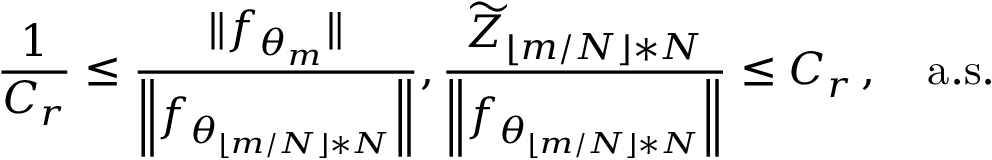<formula> <loc_0><loc_0><loc_500><loc_500>\frac { 1 } { C _ { r } } \leq \frac { \| f _ { \theta _ { m } } \| } { \left \| f _ { \theta _ { \lfloor m / N \rfloor * N } } \right \| } , \frac { \widetilde { Z } _ { \lfloor m / N \rfloor * N } } { \left \| f _ { \theta _ { \lfloor m / N \rfloor * N } } \right \| } \leq C _ { r } \, , \quad a . s .</formula> 